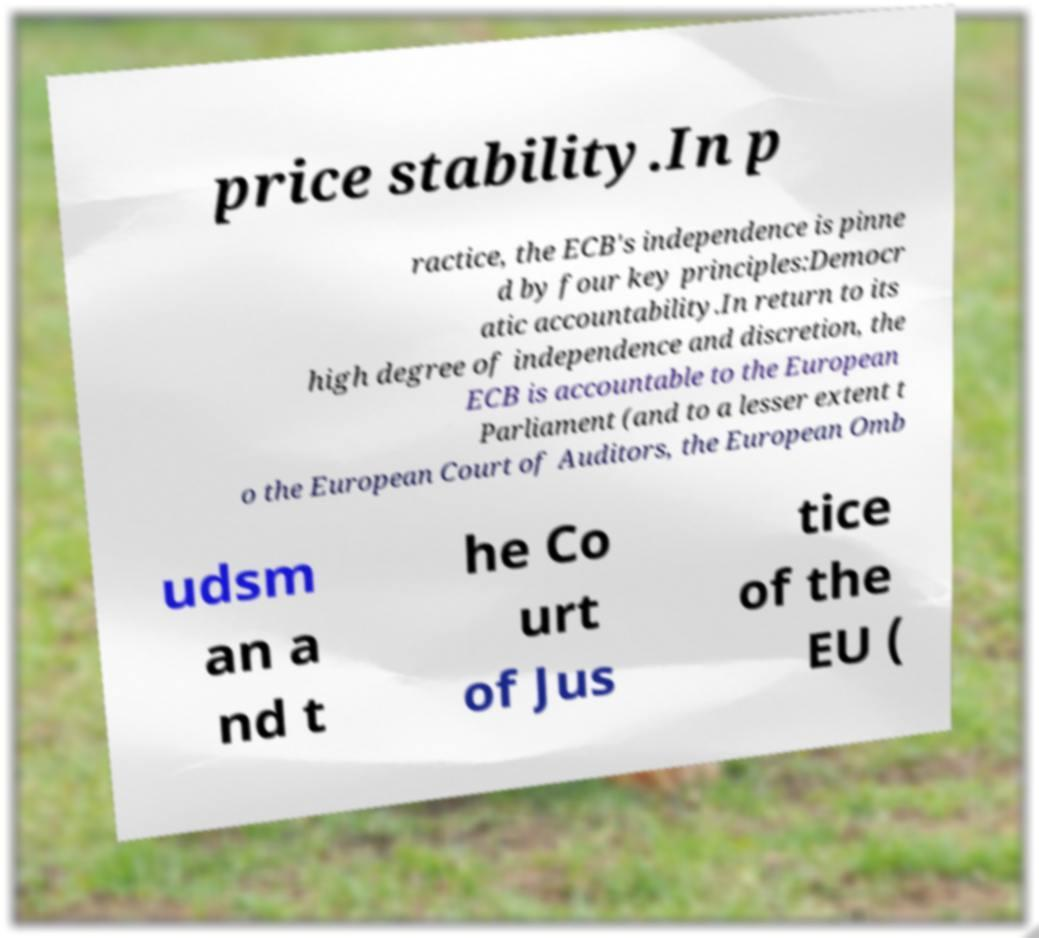Could you assist in decoding the text presented in this image and type it out clearly? price stability.In p ractice, the ECB's independence is pinne d by four key principles:Democr atic accountability.In return to its high degree of independence and discretion, the ECB is accountable to the European Parliament (and to a lesser extent t o the European Court of Auditors, the European Omb udsm an a nd t he Co urt of Jus tice of the EU ( 